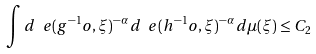Convert formula to latex. <formula><loc_0><loc_0><loc_500><loc_500>\int d _ { \ } e ( g ^ { - 1 } o , \xi ) ^ { - \alpha } \, d _ { \ } e ( h ^ { - 1 } o , \xi ) ^ { - \alpha } \, d \mu ( \xi ) \leq C _ { 2 }</formula> 